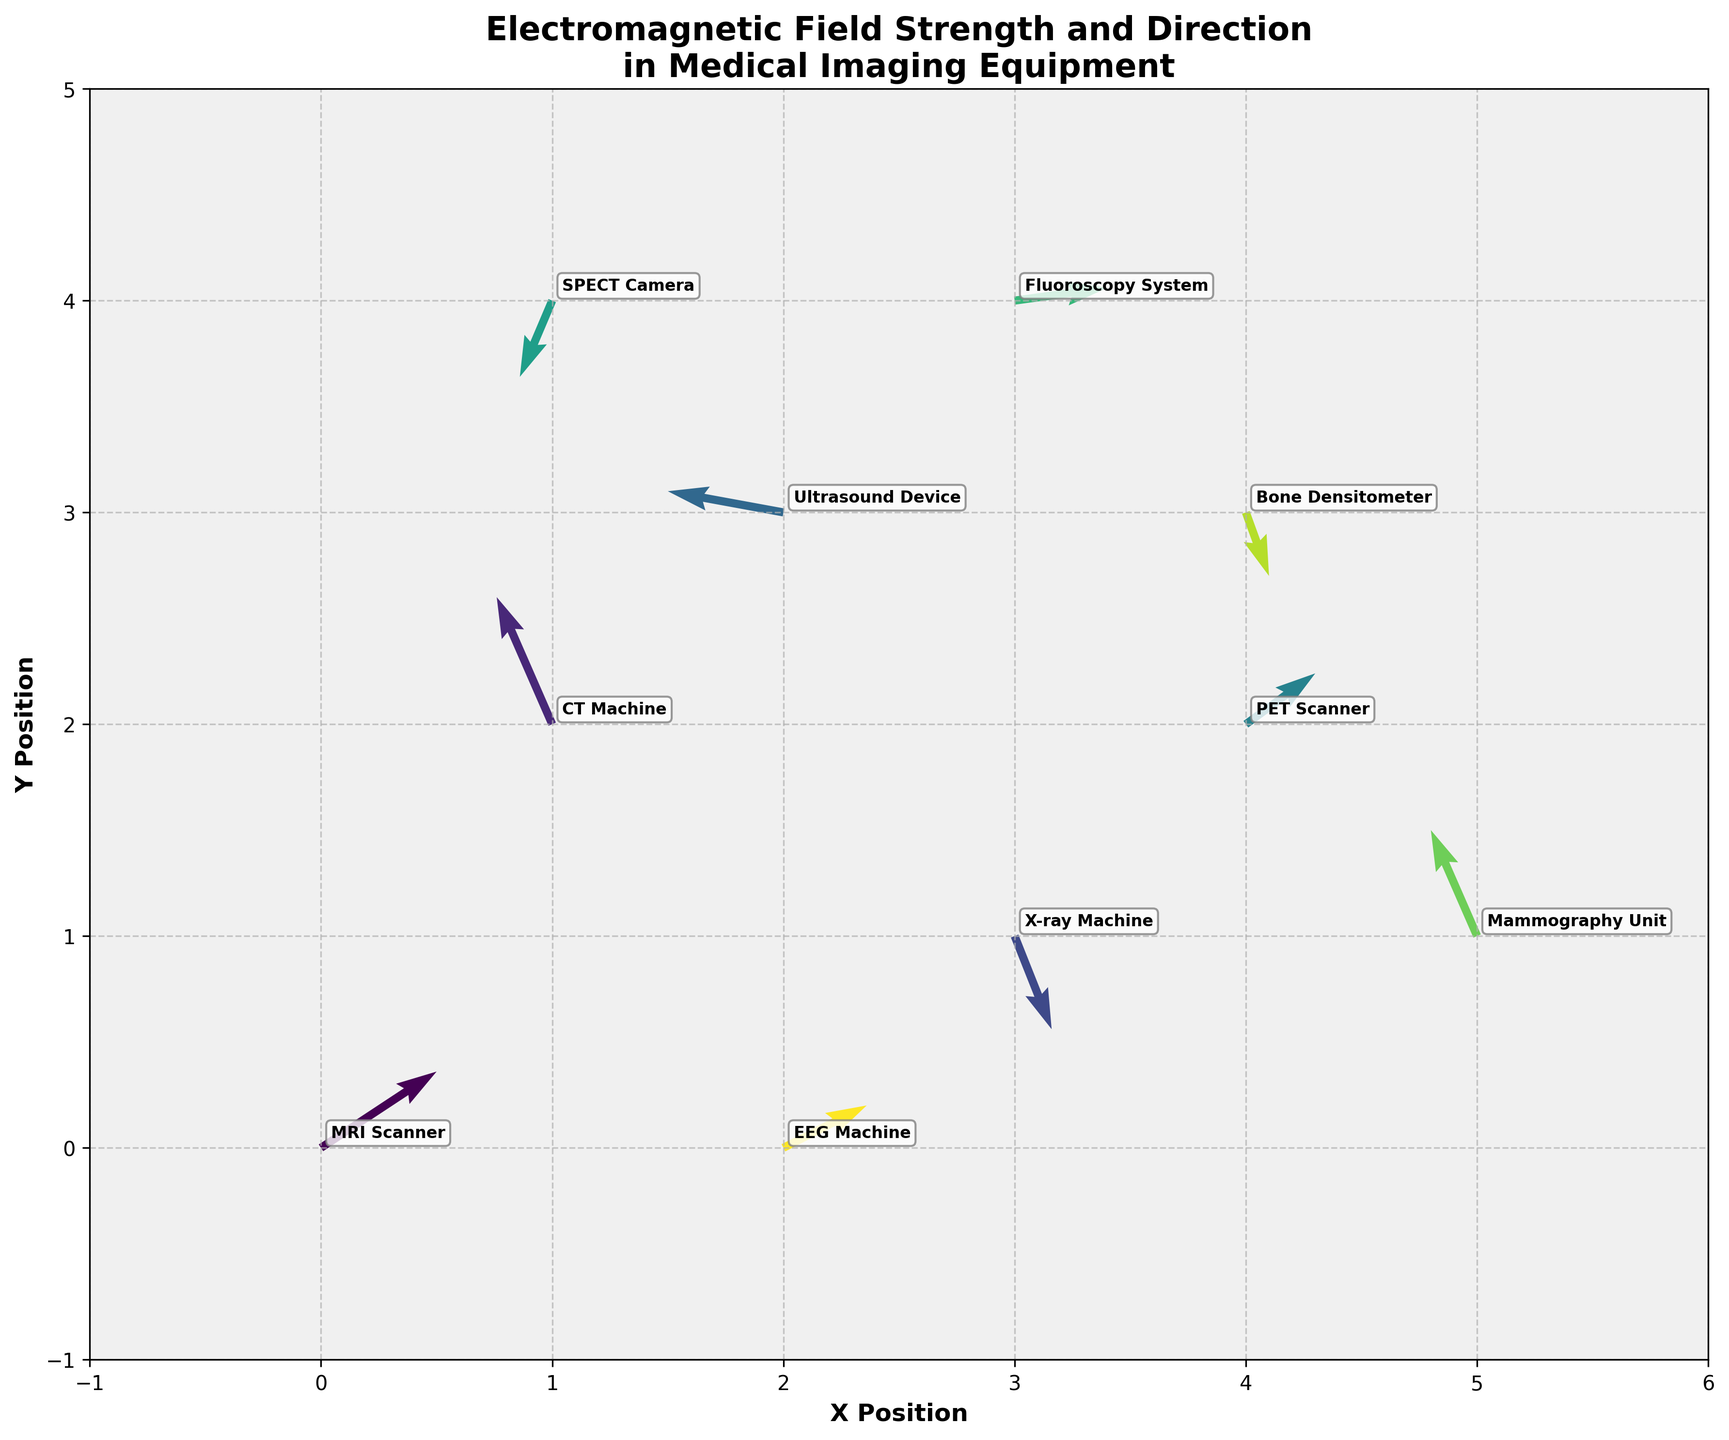What's the title of the figure? The title is displayed prominently at the top of the figure and reads "Electromagnetic Field Strength and Direction in Medical Imaging Equipment."
Answer: Electromagnetic Field Strength and Direction in Medical Imaging Equipment How many different types of medical imaging equipment are represented in the figure? The figure annotates each data point with the name of the respective medical imaging equipment. Counting these annotations, we see that there are 10 different types.
Answer: 10 Which equipment is located at the highest Y position? The Y-axis represents the vertical position. The SPECT Camera is at the highest position with coordinates (1, 4), which has the highest Y value of 4.
Answer: SPECT Camera What is the general direction of the electromagnetic field for the MRI Scanner? Looking at the quiver plot, the arrow for the MRI Scanner points approximately upwards and to the right, indicating a positive X and Y component (2.5, 1.8).
Answer: Upward and to the right Which equipment's electromagnetic field is pointing in the negative Y direction? Observing the arrows pointing down (negative Y direction), we find that the X-ray Machine, Bone Densitometer, and SPECT Camera have negative Y components.
Answer: X-ray Machine, Bone Densitometer, and SPECT Camera Which two equipment have an arrow in similar directions? By examining the orientation of arrows visually in the quiver plot, the MRI Scanner and EEG Machine have arrows pointing roughly in the same direction, both having positive X and Y components.
Answer: MRI Scanner and EEG Machine Compare the length of the arrows for the Ultrasound Device and the CT Machine. Which one represents a stronger electromagnetic field? The arrow length represents the field strength, calculated as \(\sqrt{u^2 + v^2}\). For the Ultrasound Device (u, v) = (-2.5, 0.5): \(\sqrt{(-2.5)^2 + (0.5)^2} = \sqrt{6.25 + 0.25} = \sqrt{6.5}\). For the CT Machine (u, v) = (-1.2, 3.0): \(\sqrt{(-1.2)^2 + (3.0)^2} = \sqrt{1.44 + 9} = \(\sqrt{10.44}\). Since \(\sqrt{10.44} > \(\sqrt{6.5}\), the CT Machine has a stronger field.
Answer: CT Machine Which equipment has an electromagnetic field pointing to the left and slightly upward? Looking at the direction of arrows, the Ultrasound Device at coordinates (2, 3) has an electromagnetic field with negative X and positive Y components (-2.5, 0.5), representing left and slightly upward.
Answer: Ultrasound Device Identify the equipment with the weakest electromagnetic field strength. How did you determine this? By calculating and comparing the magnitudes \(\sqrt{u^2 + v^2}\) for each device, the Bone Densitometer at (4, 3) has components (0.5, -1.5), yielding \(\sqrt{(0.5)^2 + (-1.5)^2} = \sqrt{0.25 + 2.25} = \(\sqrt{2.5}\), which is among the smallest magnitudes.
Answer: Bone Densitometer What's the primary direction of the electromagnetic field for the Fluoroscopy System, and how can you interpret this from the plot? The Fluoroscopy System at coordinates (3, 4) shows a positive X and a small positive Y component (2.0, 0.3), indicating a field directed mostly to the right.
Answer: Mostly to the right 